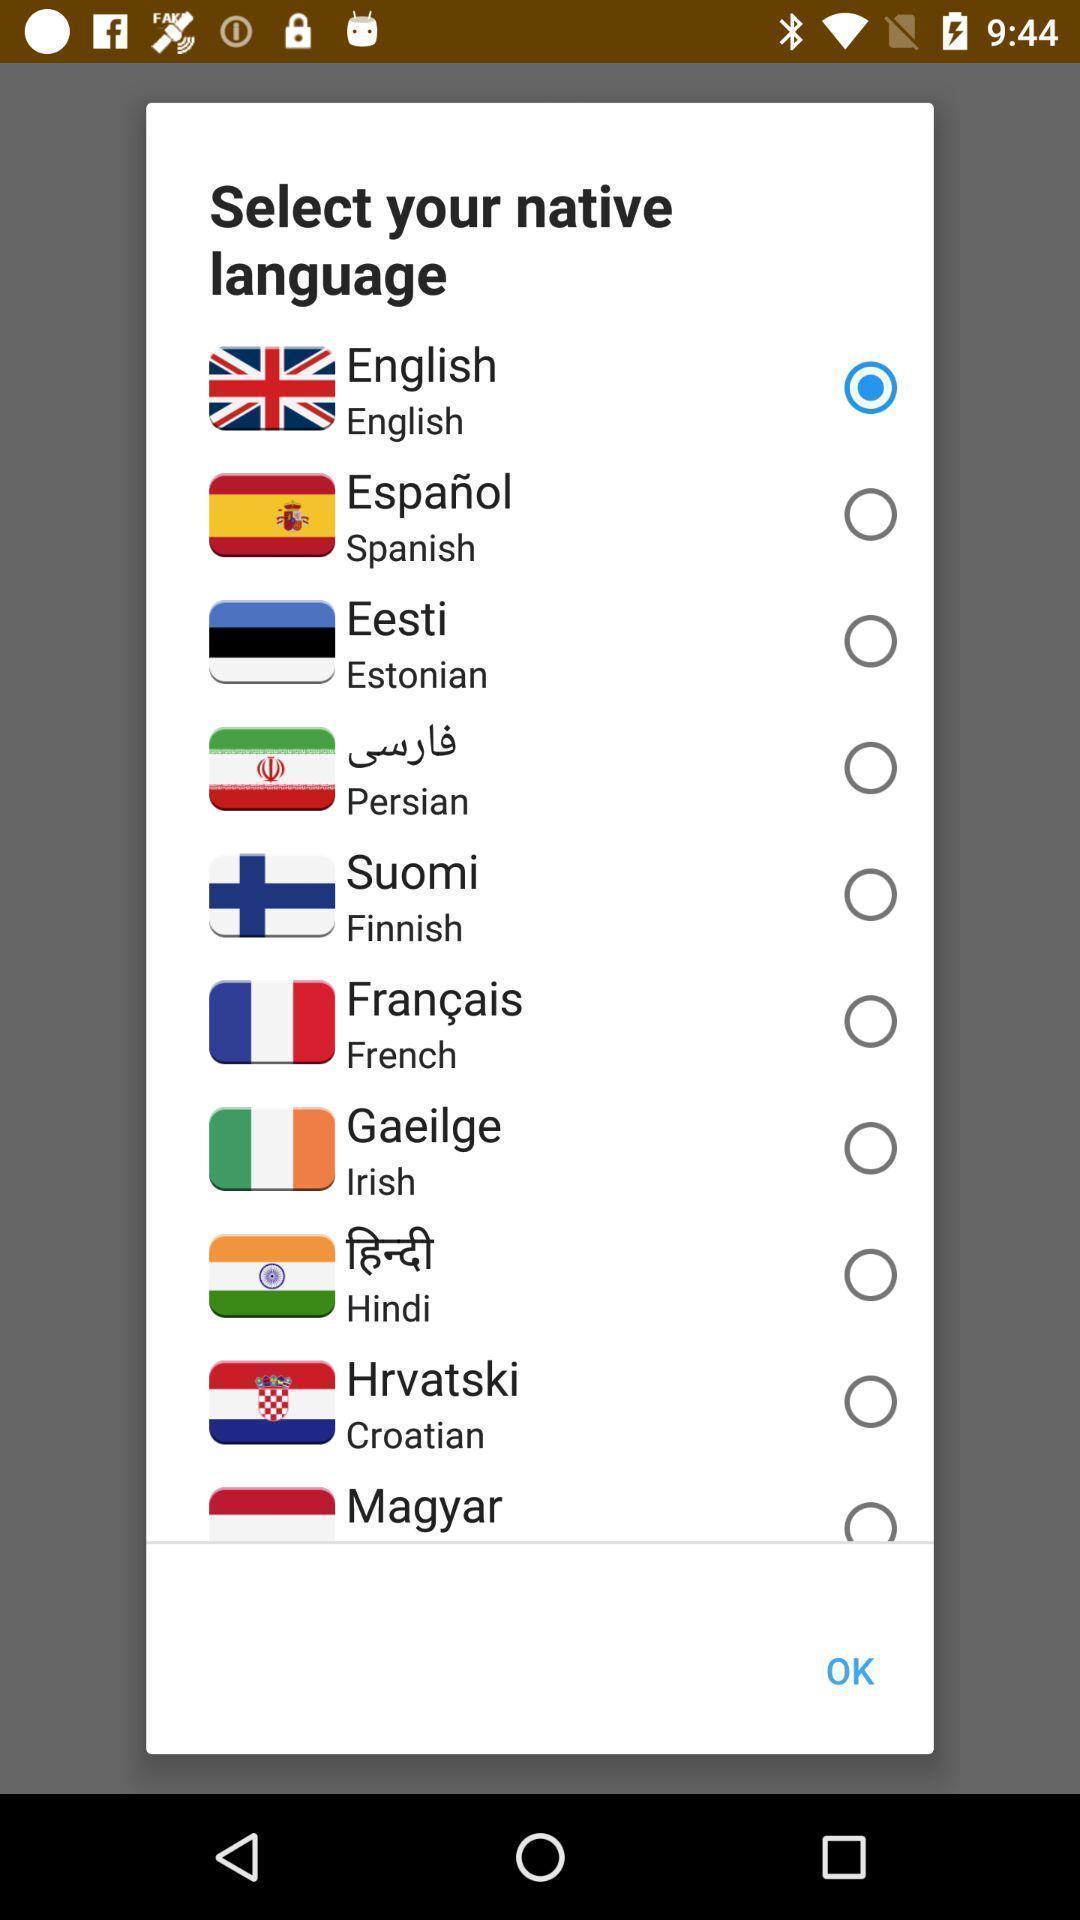Tell me about the visual elements in this screen capture. Pop-up displaying different languages to select. 